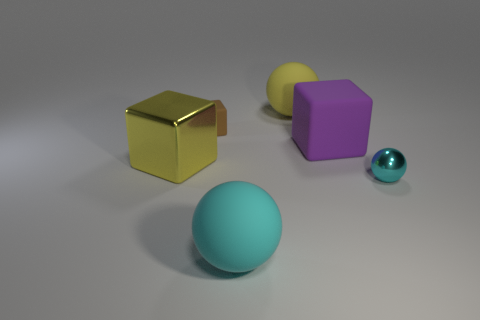How many other objects are the same color as the large metallic cube?
Ensure brevity in your answer.  1. Does the rubber object in front of the yellow metallic thing have the same color as the metal ball?
Give a very brief answer. Yes. There is a thing that is to the right of the large yellow rubber thing and behind the metal ball; what size is it?
Your response must be concise. Large. What number of other things are there of the same shape as the big cyan matte thing?
Offer a terse response. 2. How many other objects are there of the same material as the brown object?
Your answer should be very brief. 3. There is a metallic object that is the same shape as the big yellow matte object; what size is it?
Your answer should be very brief. Small. What is the color of the object that is both left of the large cyan matte thing and behind the big purple rubber object?
Offer a very short reply. Brown. How many objects are either tiny things that are left of the small cyan shiny sphere or brown spheres?
Make the answer very short. 1. What is the color of the other large object that is the same shape as the purple thing?
Keep it short and to the point. Yellow. Do the small metallic object and the shiny object to the left of the large purple thing have the same shape?
Your answer should be compact. No. 